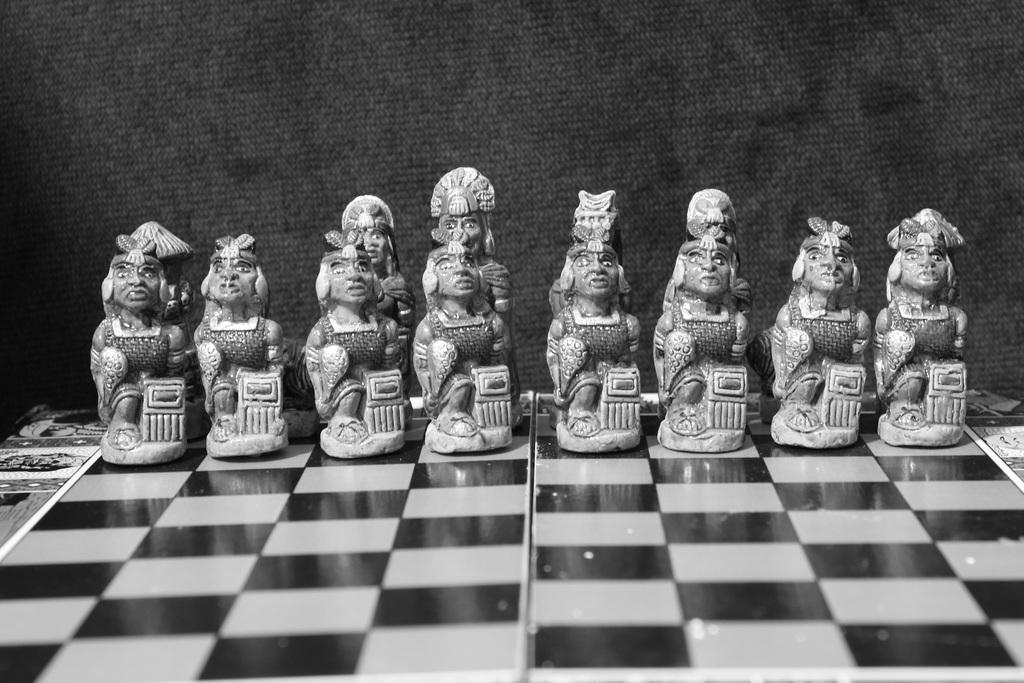What is the main object in the image? There is a chess board in the image. What is placed on the chess board? There are toys on the chess board. What can be seen in the background of the image? There is a wall visible in the background of the image. What type of pear is hanging from the chess board in the image? There is no pear present in the image; it features a chess board with toys on it. What thing is being traded on the chess board in the image? There is no trade happening on the chess board in the image; it is simply a chess board with toys on it. 